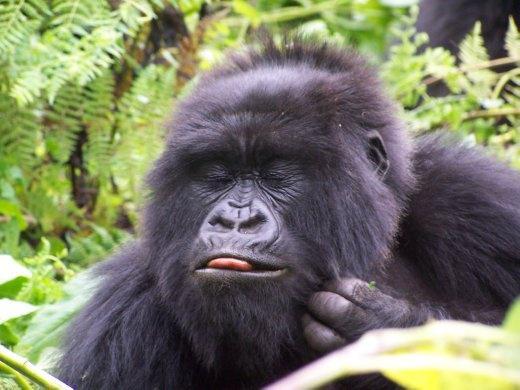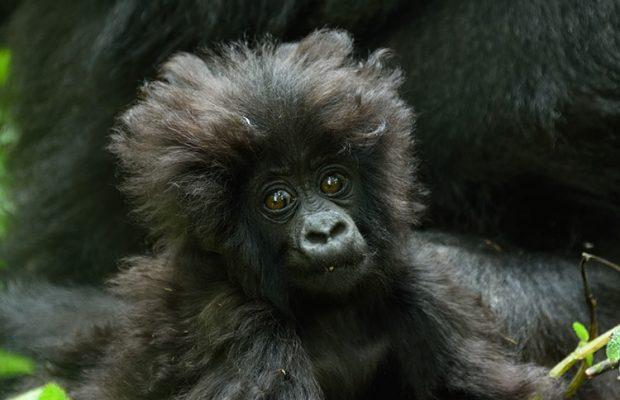The first image is the image on the left, the second image is the image on the right. Analyze the images presented: Is the assertion "At least one of the images contains exactly one gorilla." valid? Answer yes or no. Yes. The first image is the image on the left, the second image is the image on the right. Given the left and right images, does the statement "An image shows one adult ape, which is touching some part of its head with one hand." hold true? Answer yes or no. Yes. 